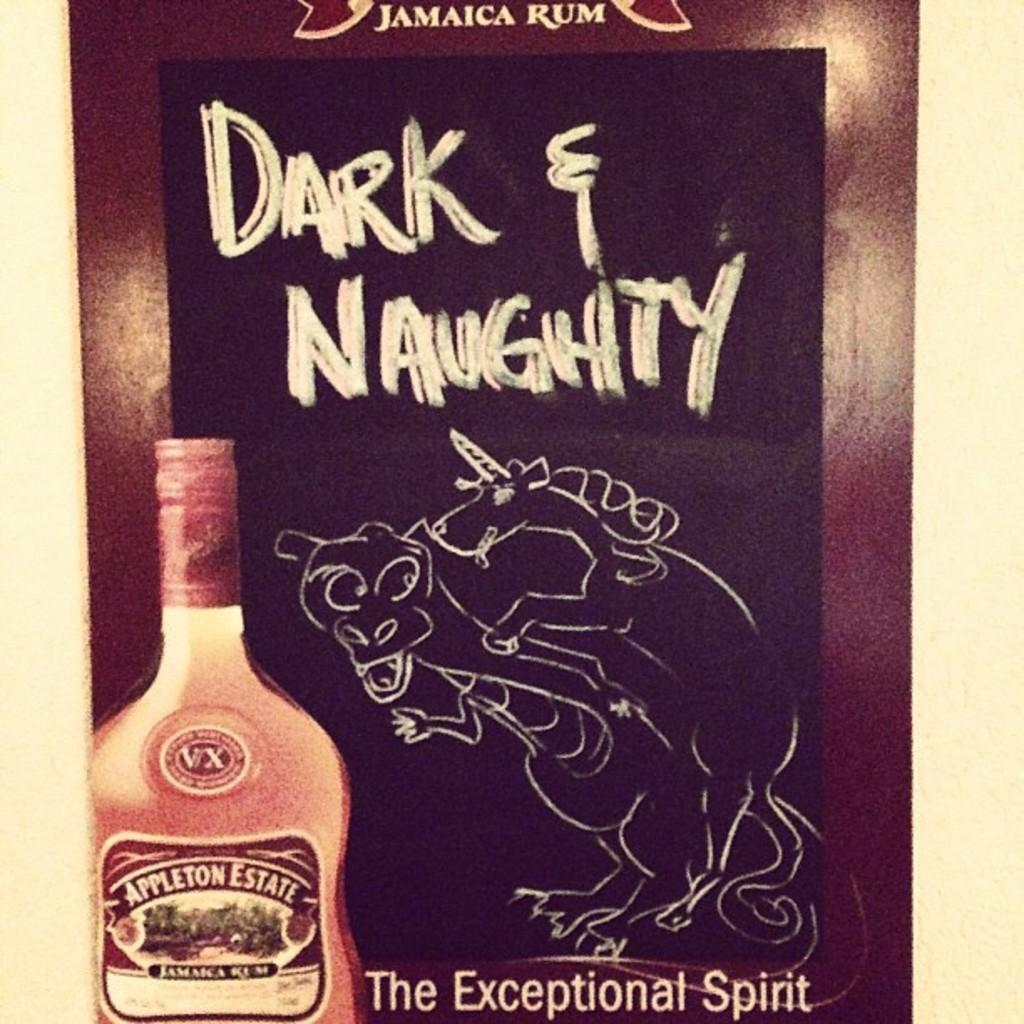<image>
Provide a brief description of the given image. Dark and Naughty appleton estate drink is shared 